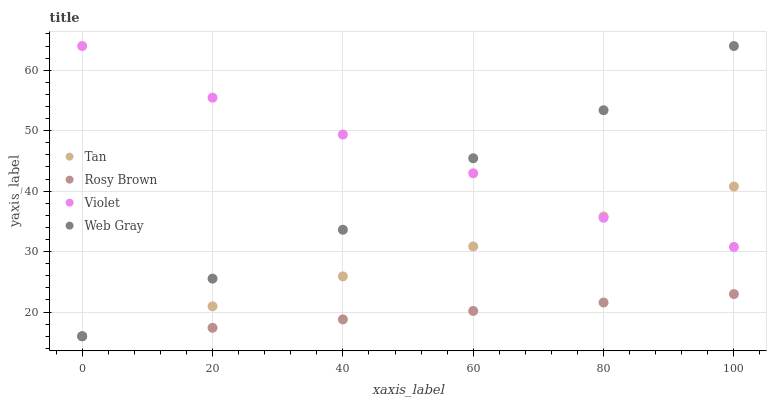Does Rosy Brown have the minimum area under the curve?
Answer yes or no. Yes. Does Violet have the maximum area under the curve?
Answer yes or no. Yes. Does Web Gray have the minimum area under the curve?
Answer yes or no. No. Does Web Gray have the maximum area under the curve?
Answer yes or no. No. Is Rosy Brown the smoothest?
Answer yes or no. Yes. Is Web Gray the roughest?
Answer yes or no. Yes. Is Web Gray the smoothest?
Answer yes or no. No. Is Rosy Brown the roughest?
Answer yes or no. No. Does Tan have the lowest value?
Answer yes or no. Yes. Does Violet have the lowest value?
Answer yes or no. No. Does Violet have the highest value?
Answer yes or no. Yes. Does Rosy Brown have the highest value?
Answer yes or no. No. Is Rosy Brown less than Violet?
Answer yes or no. Yes. Is Violet greater than Rosy Brown?
Answer yes or no. Yes. Does Rosy Brown intersect Web Gray?
Answer yes or no. Yes. Is Rosy Brown less than Web Gray?
Answer yes or no. No. Is Rosy Brown greater than Web Gray?
Answer yes or no. No. Does Rosy Brown intersect Violet?
Answer yes or no. No. 